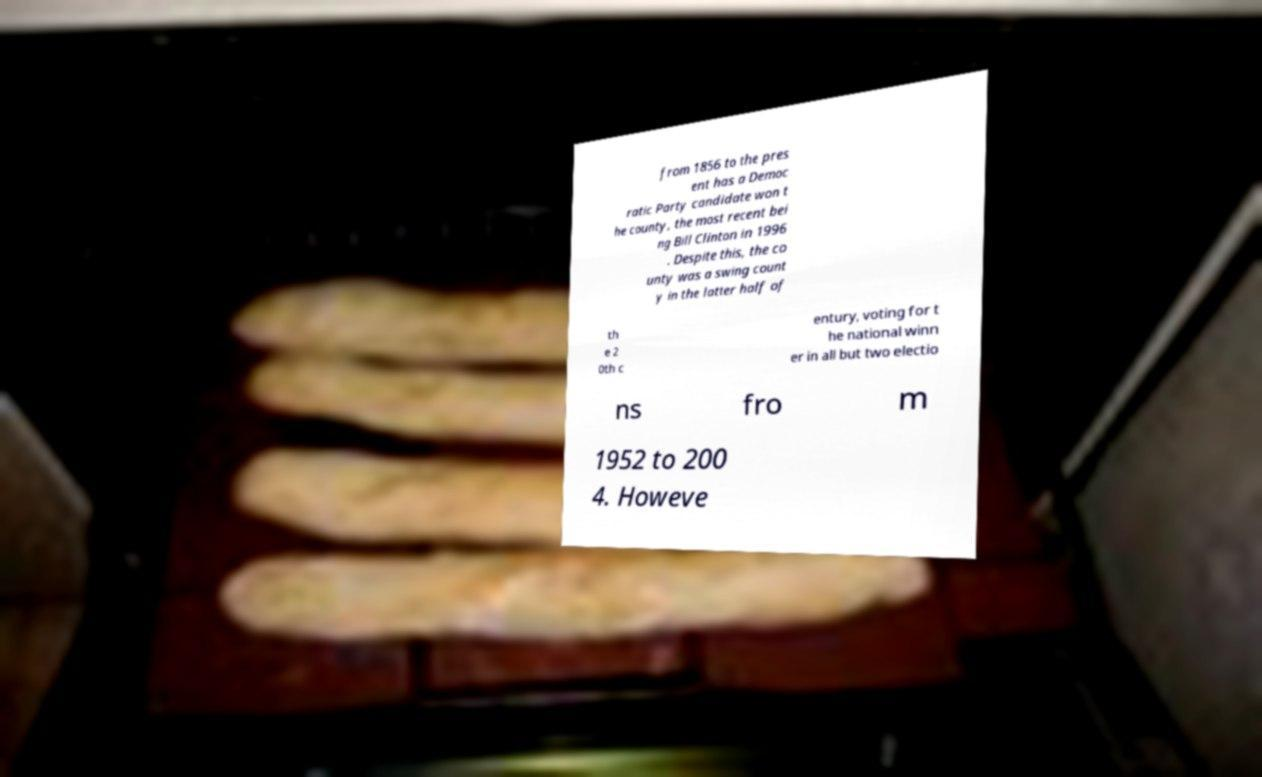For documentation purposes, I need the text within this image transcribed. Could you provide that? from 1856 to the pres ent has a Democ ratic Party candidate won t he county, the most recent bei ng Bill Clinton in 1996 . Despite this, the co unty was a swing count y in the latter half of th e 2 0th c entury, voting for t he national winn er in all but two electio ns fro m 1952 to 200 4. Howeve 